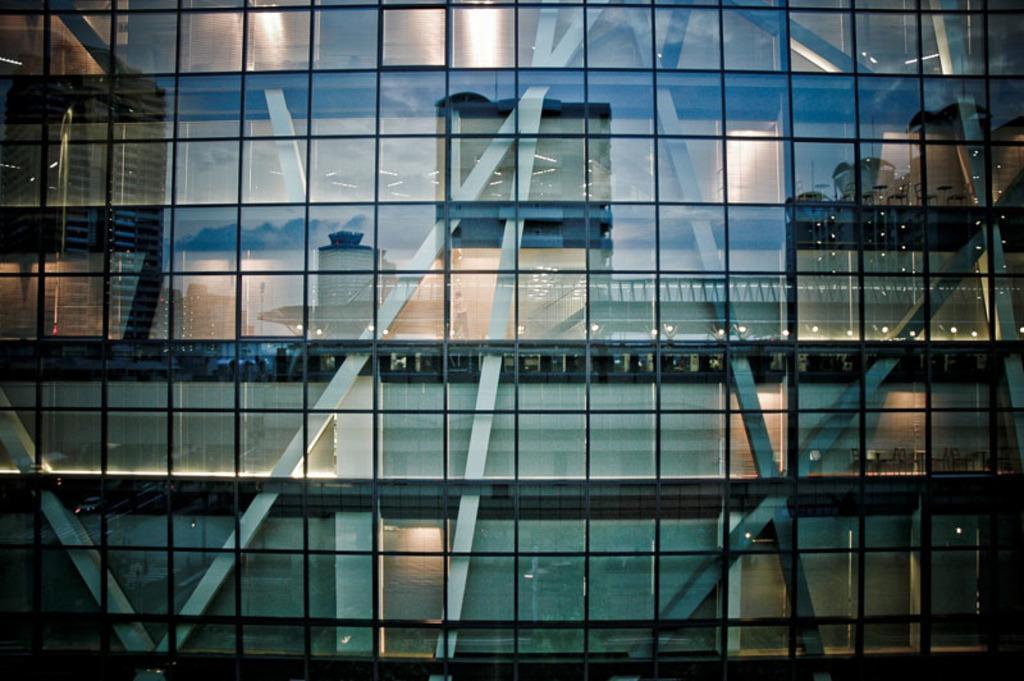Can you describe this image briefly? In the foreground of this picture we can see the building and we can see the reflections of some other buildings and the reflections of some other objects on the glasses of the building and we can see the metal rods, reflections of lights and some other objects. 